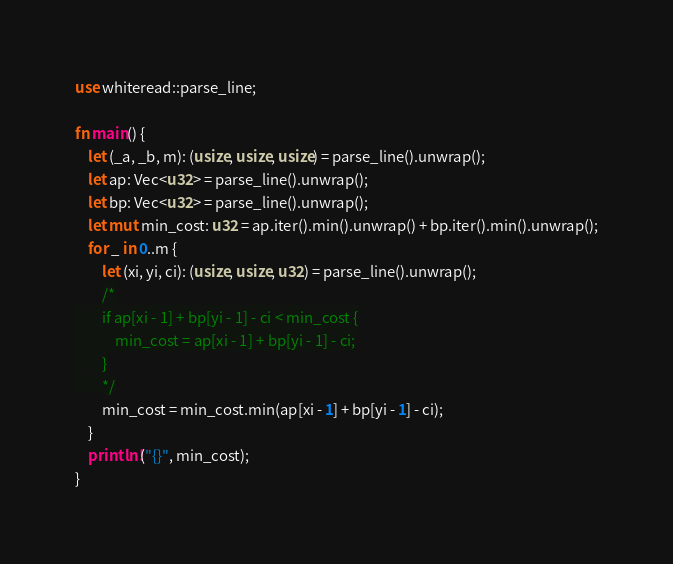Convert code to text. <code><loc_0><loc_0><loc_500><loc_500><_Rust_>use whiteread::parse_line;

fn main() {
    let (_a, _b, m): (usize, usize, usize) = parse_line().unwrap();
    let ap: Vec<u32> = parse_line().unwrap();
    let bp: Vec<u32> = parse_line().unwrap();
    let mut min_cost: u32 = ap.iter().min().unwrap() + bp.iter().min().unwrap();
    for _ in 0..m {
        let (xi, yi, ci): (usize, usize, u32) = parse_line().unwrap();
        /*
        if ap[xi - 1] + bp[yi - 1] - ci < min_cost {
            min_cost = ap[xi - 1] + bp[yi - 1] - ci;
        }
        */
        min_cost = min_cost.min(ap[xi - 1] + bp[yi - 1] - ci);
    }
    println!("{}", min_cost);
}
</code> 